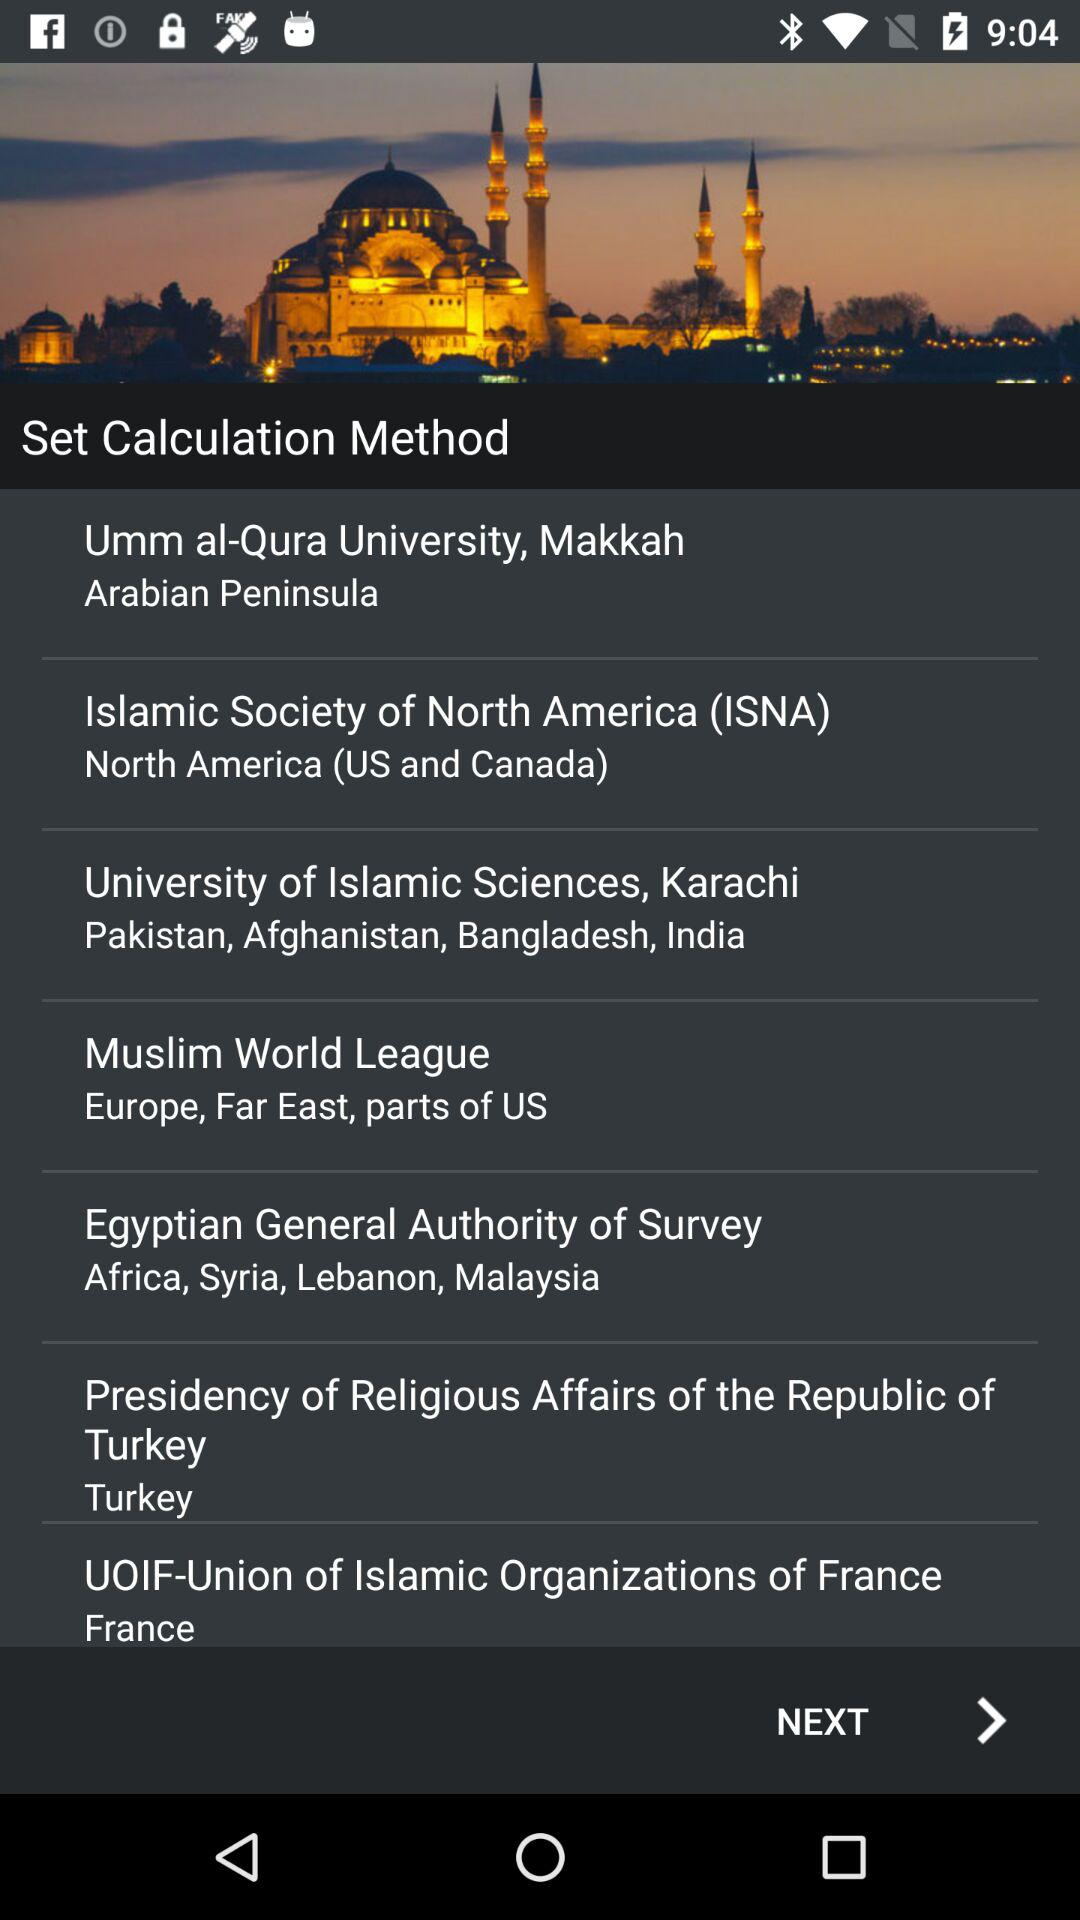How many calculation methods are available?
Answer the question using a single word or phrase. 7 